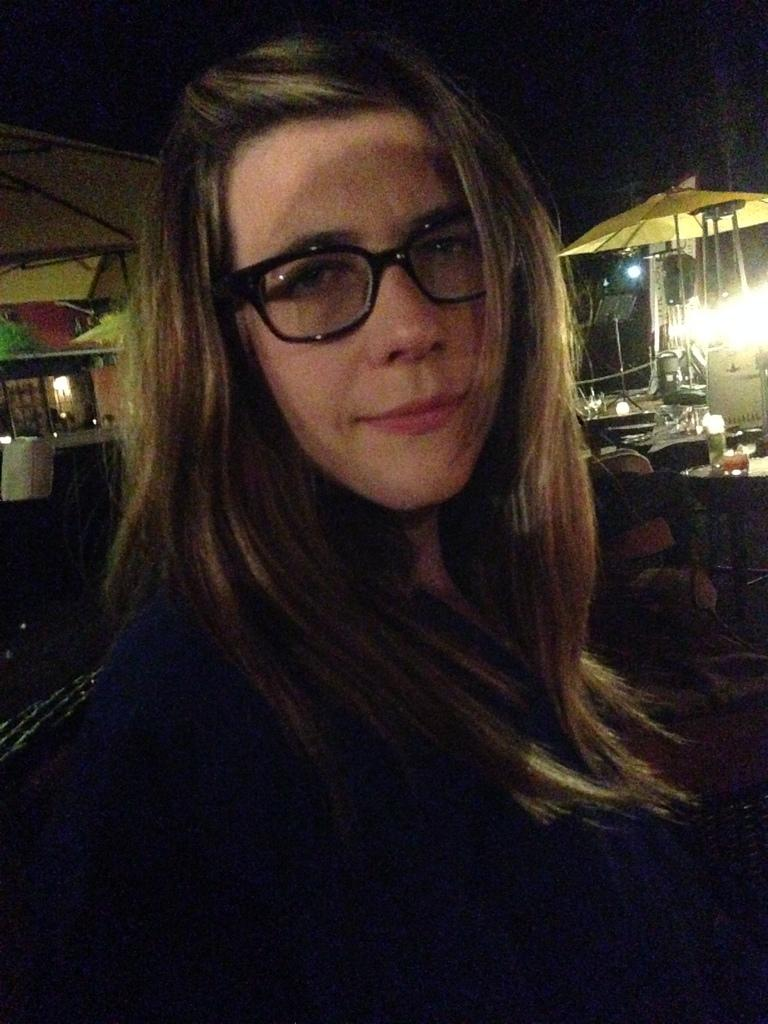Who is the main subject in the image? There is a woman in the center of the image. What can be seen in the background of the image? There is a shack, chairs, a table, and a building in the background of the image. What type of vein is visible on the woman's arm in the image? There is no visible vein on the woman's arm in the image. How many steps are required to reach the shack in the background? The number of steps required to reach the shack cannot be determined from the image alone. 